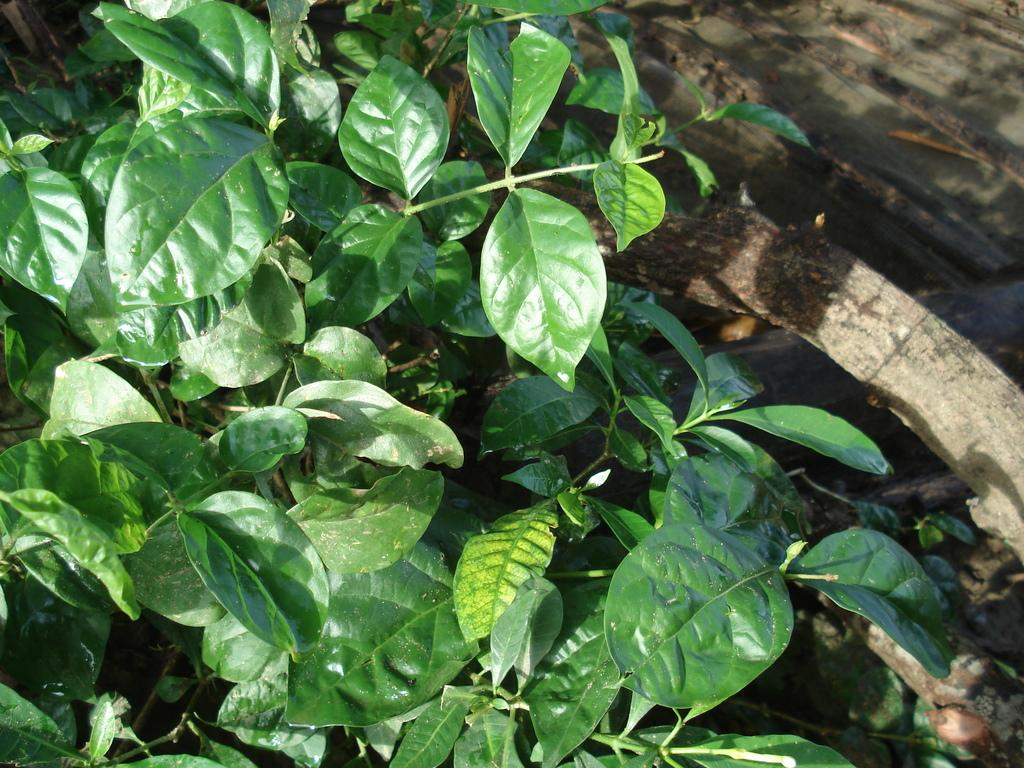What celestial bodies can be seen in the image? There are planets visible in the image. What natural object is present in the image? There is a tree trunk in the image. Where might this image have been taken? The image may have been taken in a garden, given the presence of a tree trunk. What type of treatment is being administered to the lizards in the image? There are no lizards present in the image, so no treatment can be observed. 